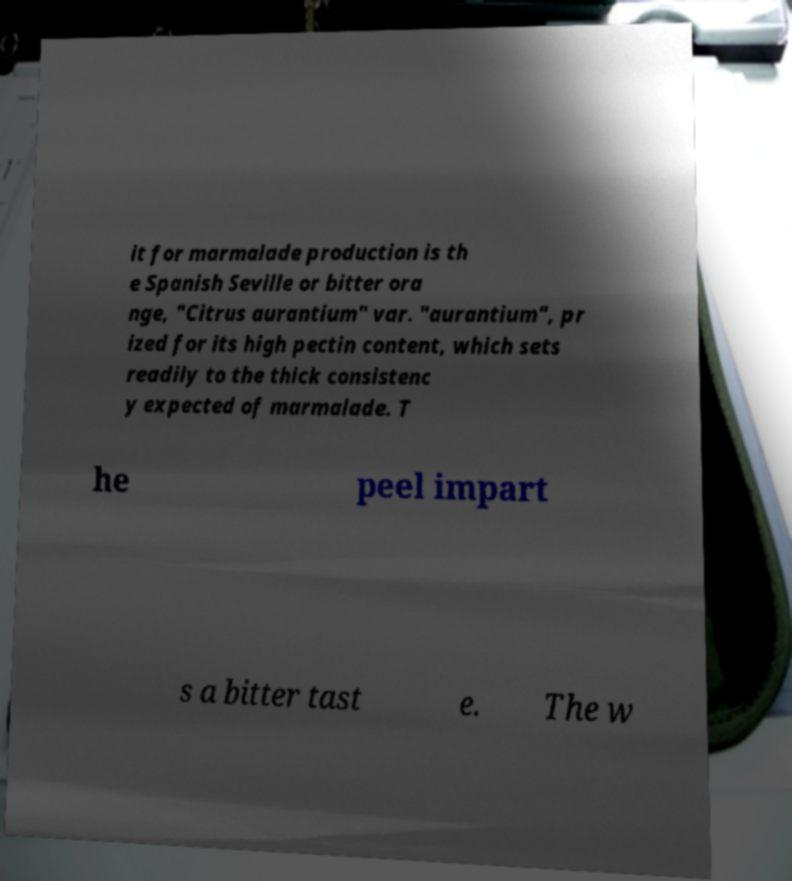Can you accurately transcribe the text from the provided image for me? it for marmalade production is th e Spanish Seville or bitter ora nge, "Citrus aurantium" var. "aurantium", pr ized for its high pectin content, which sets readily to the thick consistenc y expected of marmalade. T he peel impart s a bitter tast e. The w 